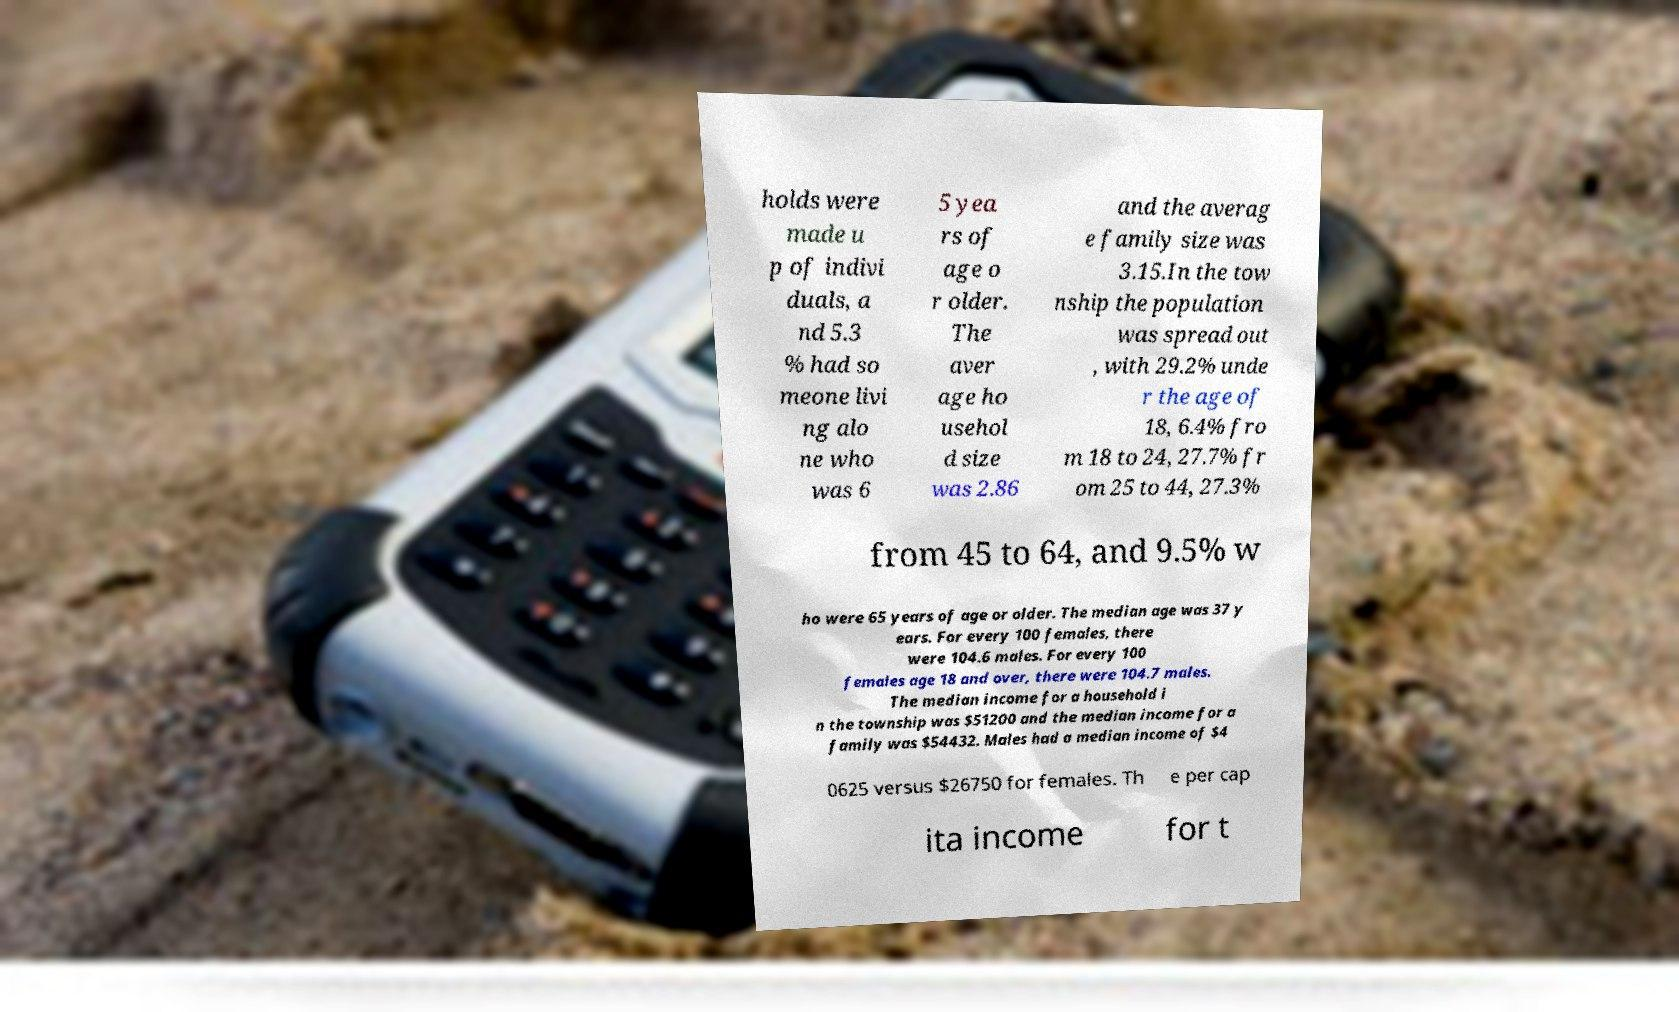Can you accurately transcribe the text from the provided image for me? holds were made u p of indivi duals, a nd 5.3 % had so meone livi ng alo ne who was 6 5 yea rs of age o r older. The aver age ho usehol d size was 2.86 and the averag e family size was 3.15.In the tow nship the population was spread out , with 29.2% unde r the age of 18, 6.4% fro m 18 to 24, 27.7% fr om 25 to 44, 27.3% from 45 to 64, and 9.5% w ho were 65 years of age or older. The median age was 37 y ears. For every 100 females, there were 104.6 males. For every 100 females age 18 and over, there were 104.7 males. The median income for a household i n the township was $51200 and the median income for a family was $54432. Males had a median income of $4 0625 versus $26750 for females. Th e per cap ita income for t 